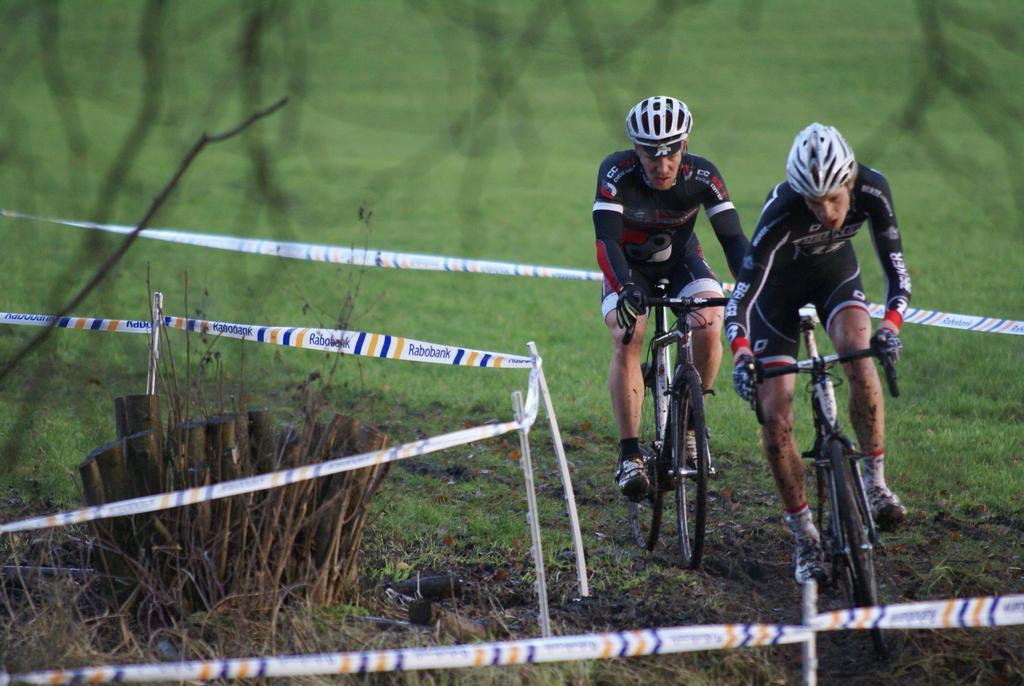How many people are in the image? There are two men in the image. What are the men doing in the image? The men are riding a bicycle. What type of clothing are the men wearing? The men are wearing sport dress. What safety equipment are the men using? The men have helmets on their heads. What can be seen in the background of the image? There is a fence and green grass in the image. What type of selection process is being used by the authority figure in the image? There is no authority figure present in the image, and no selection process is taking place. 